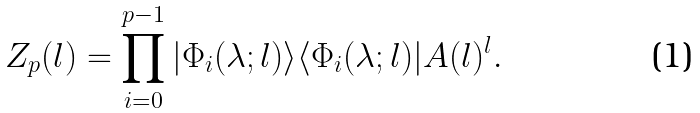Convert formula to latex. <formula><loc_0><loc_0><loc_500><loc_500>Z _ { p } ( l ) = \prod _ { i = 0 } ^ { p - 1 } | \Phi _ { i } ( \lambda ; l ) \rangle \langle \Phi _ { i } ( \lambda ; l ) | A ( l ) ^ { l } .</formula> 